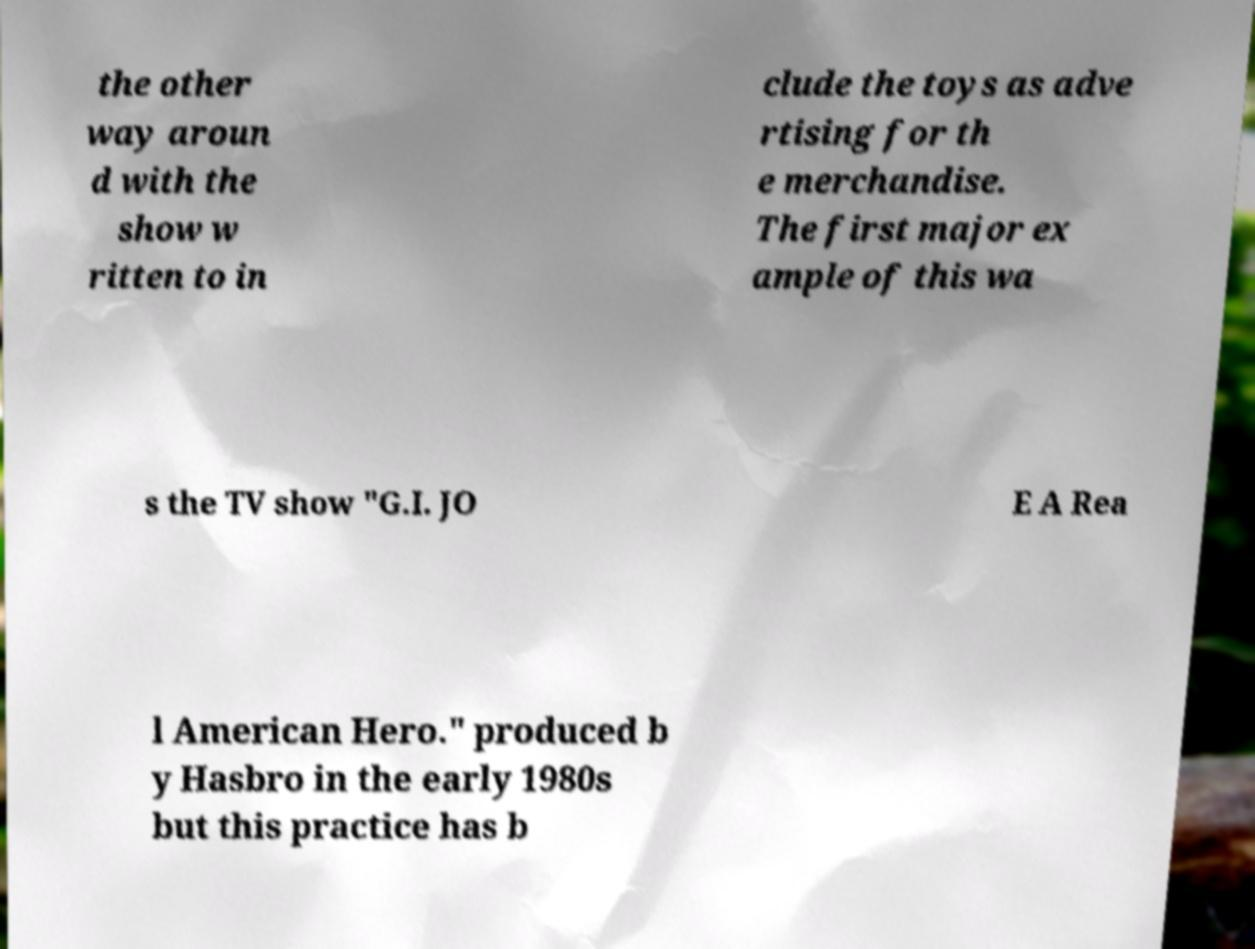For documentation purposes, I need the text within this image transcribed. Could you provide that? the other way aroun d with the show w ritten to in clude the toys as adve rtising for th e merchandise. The first major ex ample of this wa s the TV show "G.I. JO E A Rea l American Hero." produced b y Hasbro in the early 1980s but this practice has b 